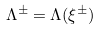<formula> <loc_0><loc_0><loc_500><loc_500>\Lambda ^ { \pm } = \Lambda ( \xi ^ { \pm } )</formula> 